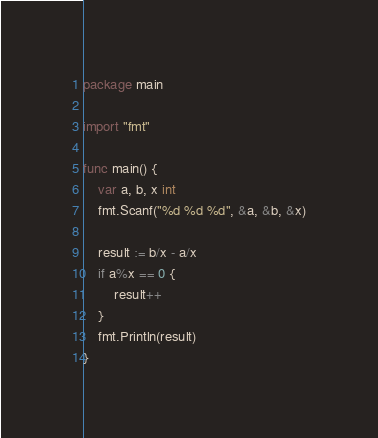Convert code to text. <code><loc_0><loc_0><loc_500><loc_500><_Go_>package main

import "fmt"

func main() {
	var a, b, x int
	fmt.Scanf("%d %d %d", &a, &b, &x)

	result := b/x - a/x
	if a%x == 0 {
		result++
	}
	fmt.Println(result)
}</code> 